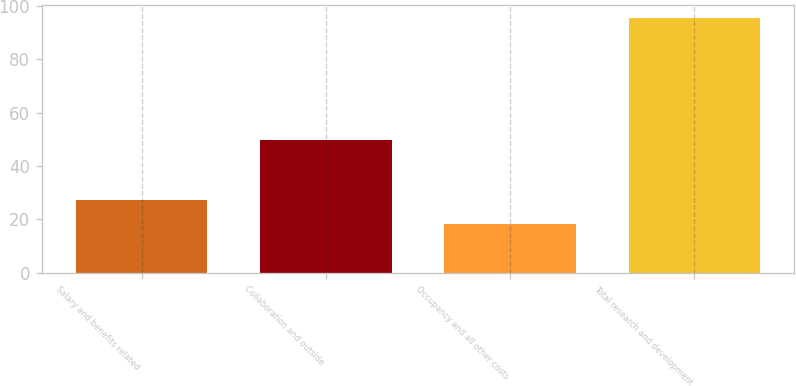Convert chart. <chart><loc_0><loc_0><loc_500><loc_500><bar_chart><fcel>Salary and benefits related<fcel>Collaboration and outside<fcel>Occupancy and all other costs<fcel>Total research and development<nl><fcel>27.3<fcel>49.9<fcel>18.4<fcel>95.6<nl></chart> 